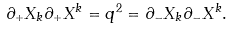Convert formula to latex. <formula><loc_0><loc_0><loc_500><loc_500>\partial _ { + } X _ { k } \partial _ { + } X ^ { k } = q ^ { 2 } = \partial _ { - } X _ { k } \partial _ { - } X ^ { k } .</formula> 